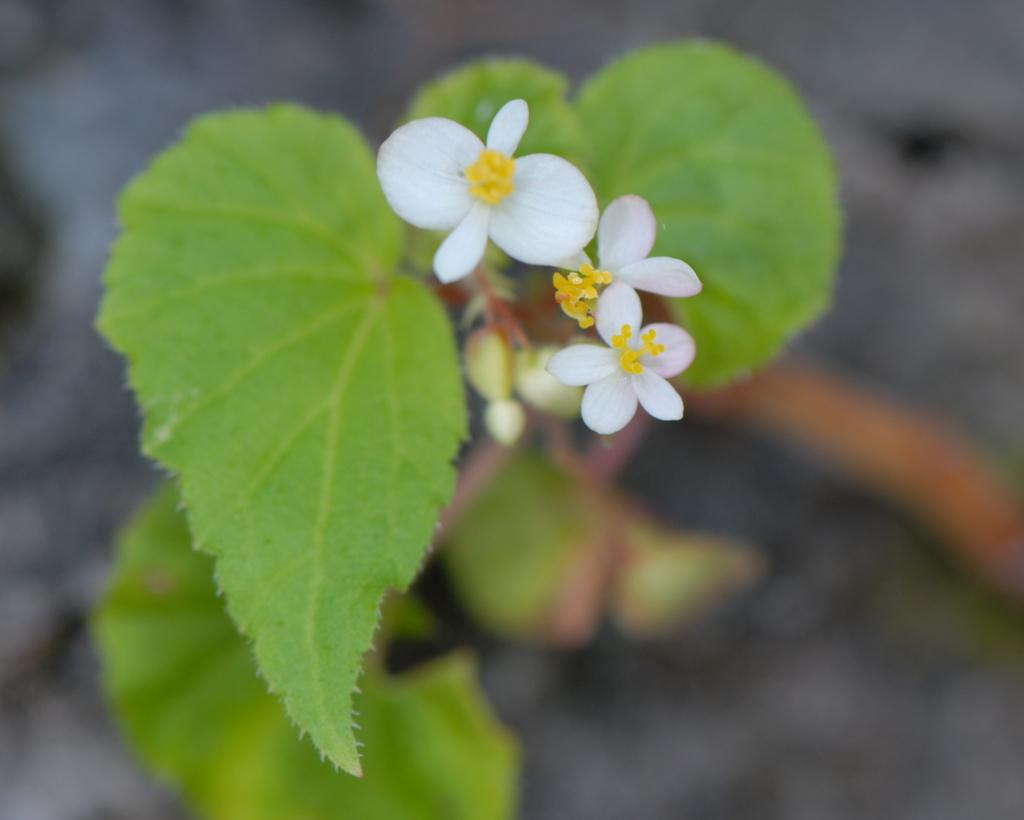What can be seen in the foreground of the picture? There are flowers and leaves in the foreground of the picture. Can you describe the background of the image? The background of the image is blurred. What type of beast can be seen hiding behind the flowers in the image? There is no beast present in the image; it only features flowers and leaves in the foreground. 